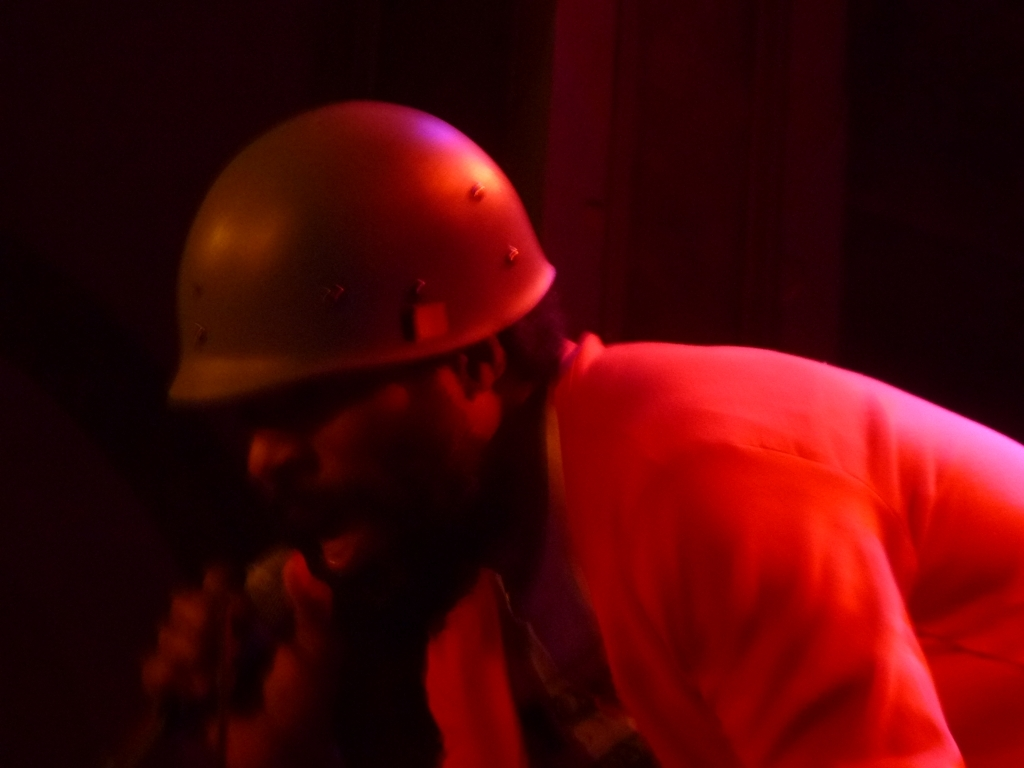How would you rate the quality of this image? A. Good B. Average C. Very poor D. Excellent I would rate the quality of this image as 'B' Average, considering the evident issues with lighting and focus which detract from the image's clarity. However, the subject remains identifiable, and the image captures a candid moment, which may convey certain emotions or atmosphere despite its technical limitations. 